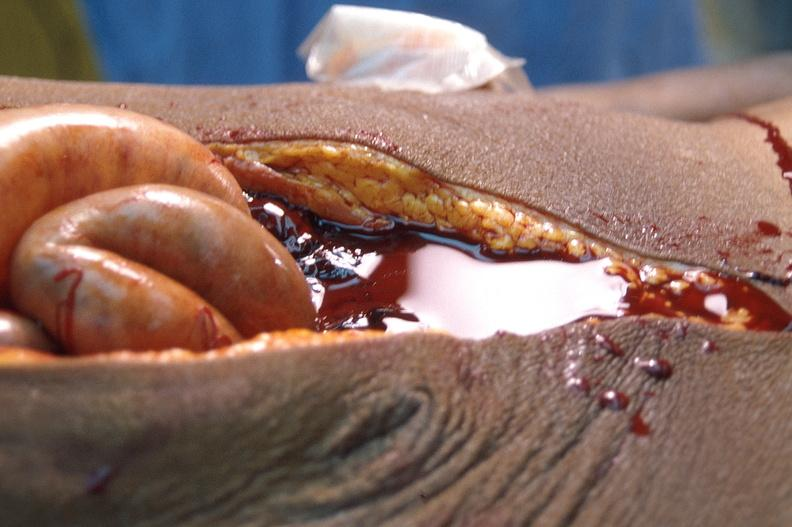what does this image show?
Answer the question using a single word or phrase. Ascites 